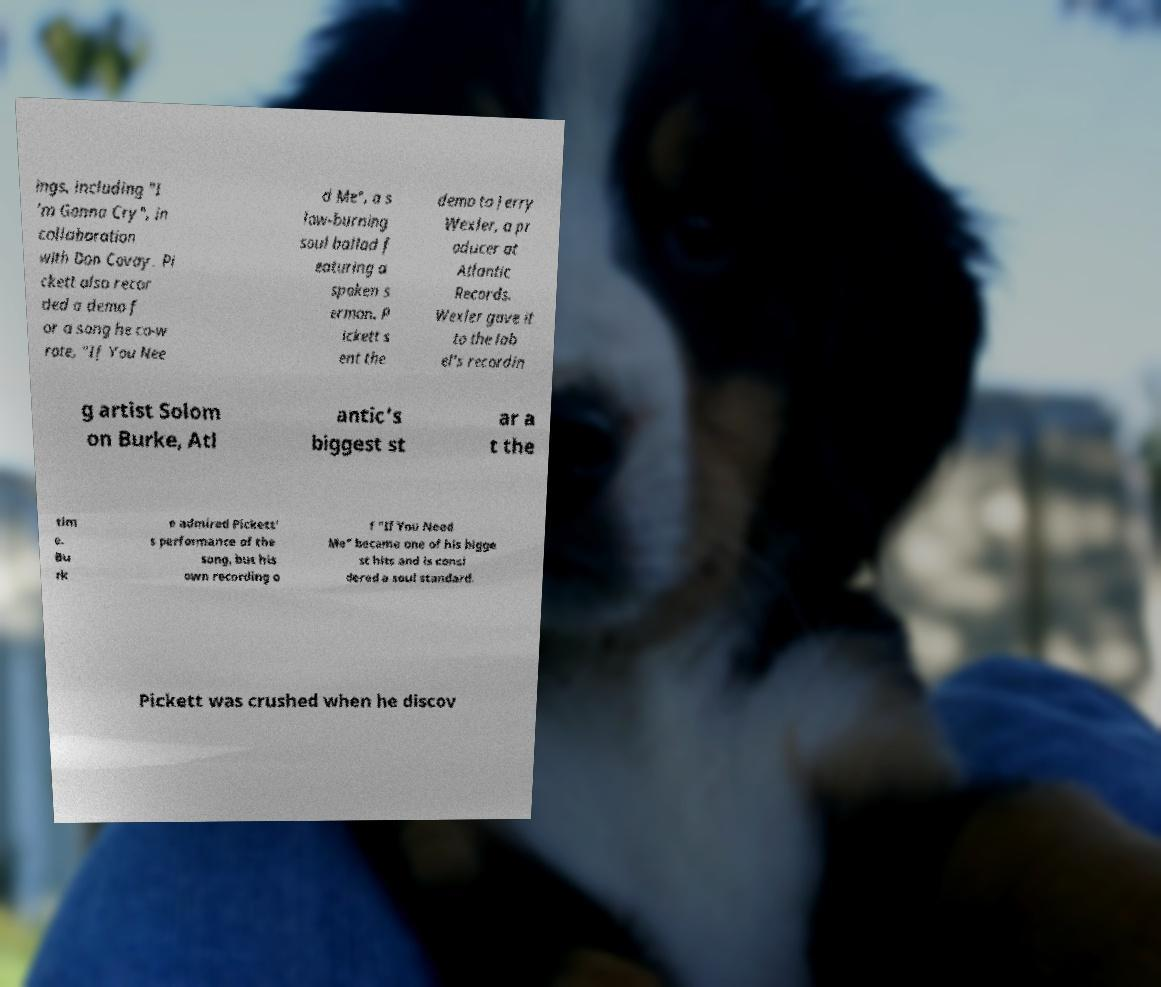There's text embedded in this image that I need extracted. Can you transcribe it verbatim? ings, including "I 'm Gonna Cry", in collaboration with Don Covay. Pi ckett also recor ded a demo f or a song he co-w rote, "If You Nee d Me", a s low-burning soul ballad f eaturing a spoken s ermon. P ickett s ent the demo to Jerry Wexler, a pr oducer at Atlantic Records. Wexler gave it to the lab el's recordin g artist Solom on Burke, Atl antic's biggest st ar a t the tim e. Bu rk e admired Pickett' s performance of the song, but his own recording o f "If You Need Me" became one of his bigge st hits and is consi dered a soul standard. Pickett was crushed when he discov 